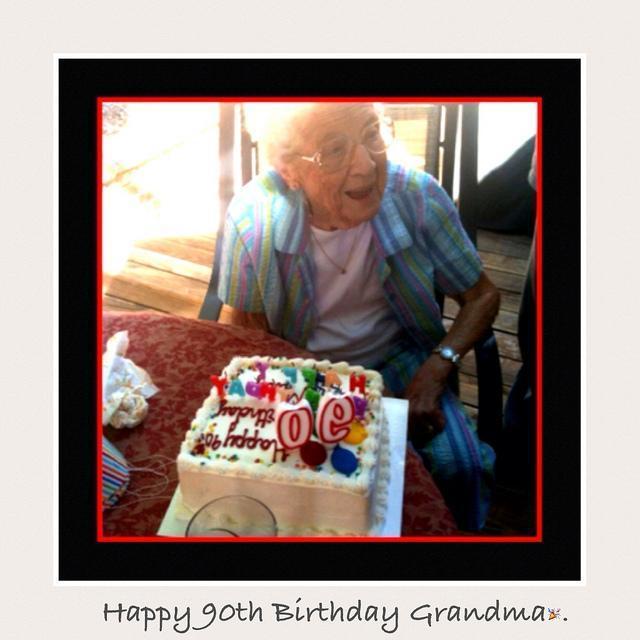How many people are wearing orange shirts?
Give a very brief answer. 0. 